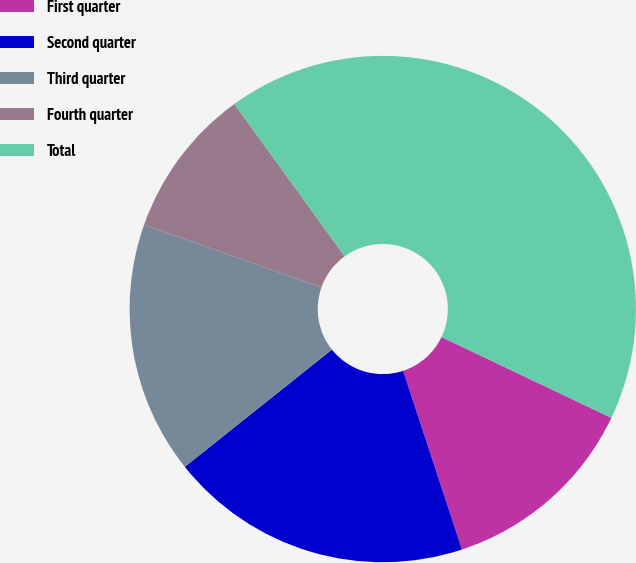Convert chart. <chart><loc_0><loc_0><loc_500><loc_500><pie_chart><fcel>First quarter<fcel>Second quarter<fcel>Third quarter<fcel>Fourth quarter<fcel>Total<nl><fcel>12.87%<fcel>19.35%<fcel>16.11%<fcel>9.63%<fcel>42.04%<nl></chart> 